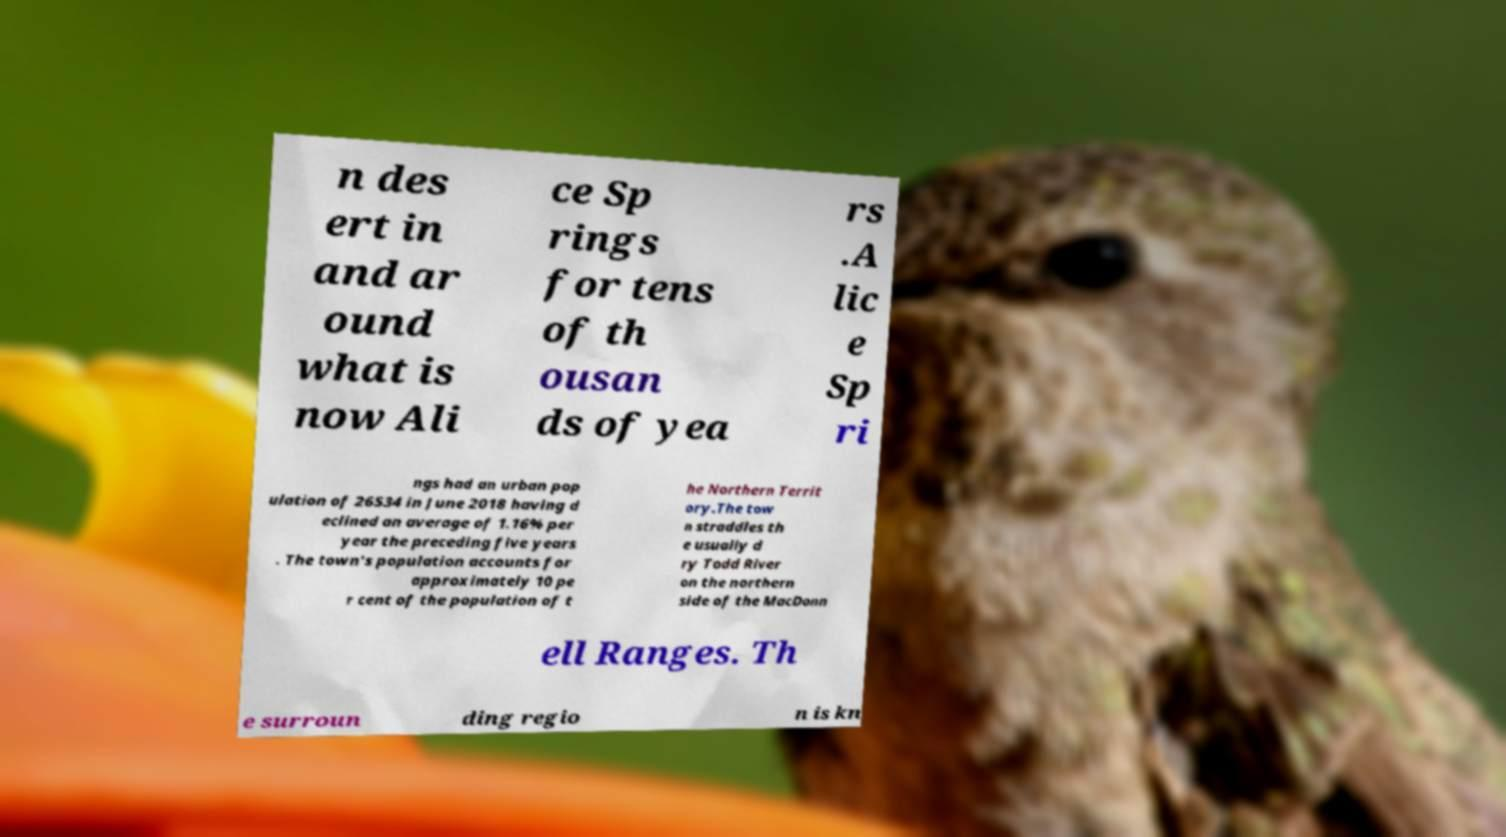What messages or text are displayed in this image? I need them in a readable, typed format. n des ert in and ar ound what is now Ali ce Sp rings for tens of th ousan ds of yea rs .A lic e Sp ri ngs had an urban pop ulation of 26534 in June 2018 having d eclined an average of 1.16% per year the preceding five years . The town's population accounts for approximately 10 pe r cent of the population of t he Northern Territ ory.The tow n straddles th e usually d ry Todd River on the northern side of the MacDonn ell Ranges. Th e surroun ding regio n is kn 